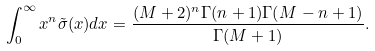Convert formula to latex. <formula><loc_0><loc_0><loc_500><loc_500>\int _ { 0 } ^ { \infty } x ^ { n } \tilde { \sigma } ( x ) d x = \frac { ( M + 2 ) ^ { n } \Gamma ( n + 1 ) \Gamma ( M - n + 1 ) } { \Gamma ( M + 1 ) } .</formula> 